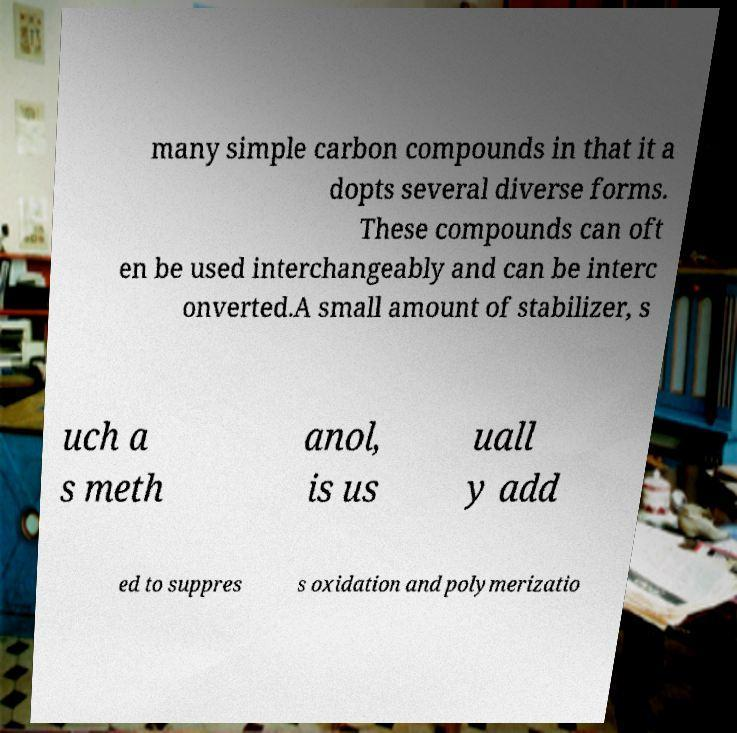Could you assist in decoding the text presented in this image and type it out clearly? many simple carbon compounds in that it a dopts several diverse forms. These compounds can oft en be used interchangeably and can be interc onverted.A small amount of stabilizer, s uch a s meth anol, is us uall y add ed to suppres s oxidation and polymerizatio 